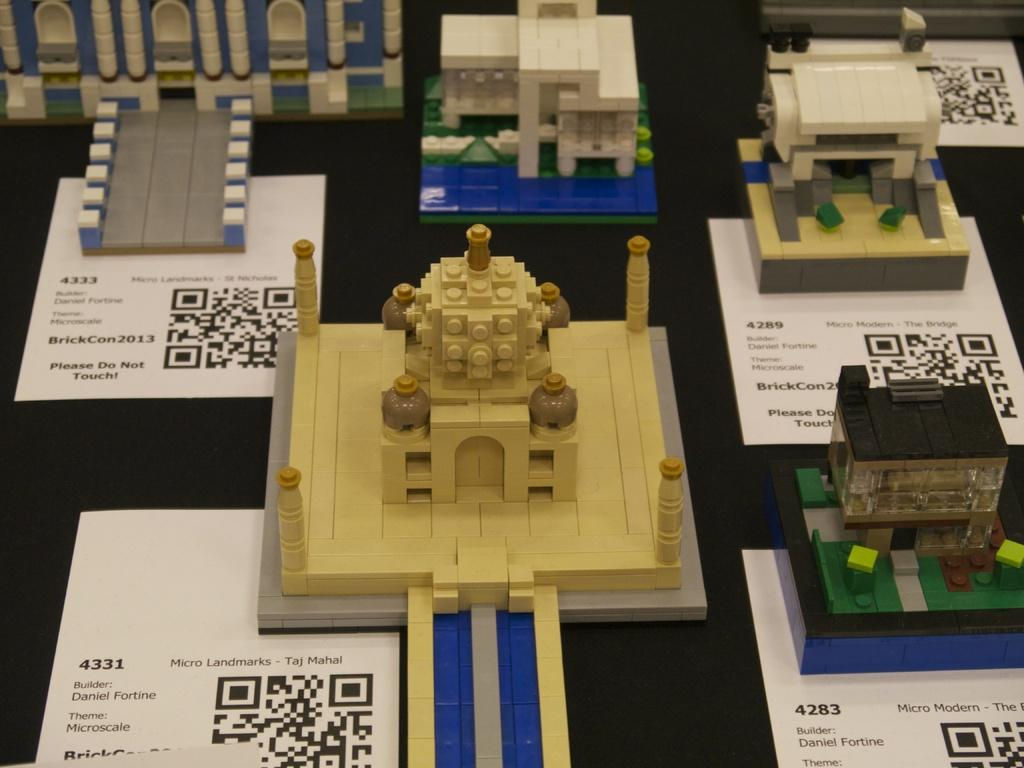What type of objects are in the image? There are miniatures in the image. What colors are the miniatures? The miniatures are in brown and cream colors. What color is the floor in the image? The floor in the image is black. How many mice are playing with a heart-shaped shoe in the image? There are no mice or heart-shaped shoe present in the image. 